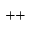Convert formula to latex. <formula><loc_0><loc_0><loc_500><loc_500>^ { + + }</formula> 